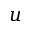Convert formula to latex. <formula><loc_0><loc_0><loc_500><loc_500>u</formula> 